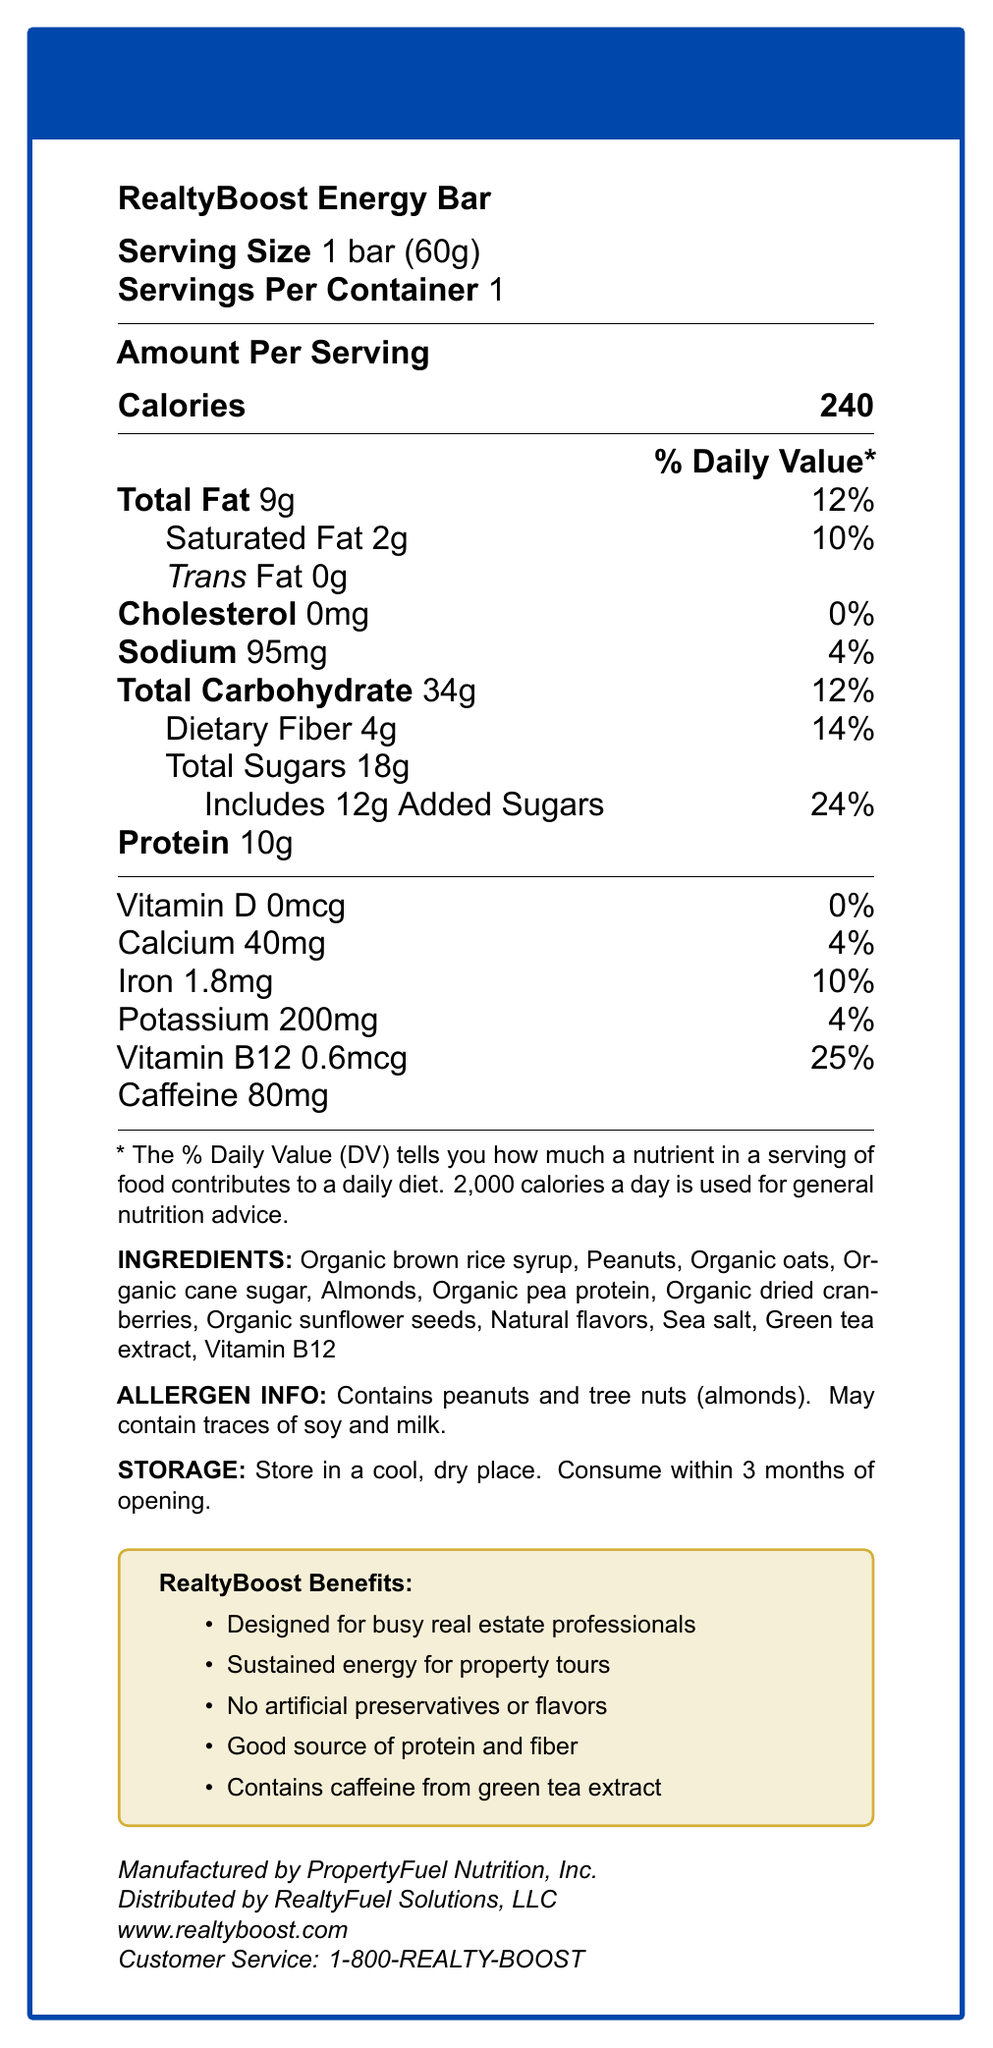How many calories are in one serving of RealtyBoost Energy Bar? The document states that one serving of the RealtyBoost Energy Bar contains 240 calories.
Answer: 240 What is the serving size for the RealtyBoost Energy Bar? The serving size is specified as "1 bar (60g)" in the document.
Answer: 1 bar (60g) What percentage of the daily value of calcium does one serving provide? The document mentions that one serving of the energy bar provides 4% of the daily value for calcium.
Answer: 4% Does the RealtyBoost Energy Bar contain any cholesterol? The document lists "Cholesterol 0mg" with a daily value of "0%", indicating no cholesterol content.
Answer: No What is the total amount of carbohydrates in one serving? The document indicates that one serving contains 34 grams of total carbohydrates.
Answer: 34g Which ingredient in the RealtyBoost Energy Bar contains caffeine? The document lists caffeine content and mentions "Green tea extract" as an ingredient, implying that caffeine comes from green tea extract.
Answer: Green tea extract How much dietary fiber does one bar contain? The document notes that one serving contains 4 grams of dietary fiber.
Answer: 4g Where should the RealtyBoost Energy Bar be stored? The storage instructions specify that the bar should be stored in a cool, dry place.
Answer: In a cool, dry place What is the daily value percentage of saturated fat in one serving? According to the document, the daily value percentage for saturated fat is 10%.
Answer: 10% How many grams of protein does one serving provide? The document states that one serving provides 10 grams of protein.
Answer: 10g What is the name of the manufacturer of RealtyBoost Energy Bar? The manufacturer is listed as PropertyFuel Nutrition, Inc.
Answer: PropertyFuel Nutrition, Inc. Who distributes the RealtyBoost Energy Bar? A. PropertyFuel Nutrition, Inc. B. RealtyFuel Solutions, LLC C. Green Tea Extract Co. D. Real Estate Agents Association The document states that RealtyFuel Solutions, LLC is the distributor of the energy bar.
Answer: B What is the daily value percentage of iron in one serving? i. 4% ii. 10% iii. 14% iv. 24% The document lists the daily value percentage of iron as 10%.
Answer: ii Does the RealtyBoost Energy Bar contain any artificial preservatives or flavors? One of the marketing claims is that there are no artificial preservatives or flavors in the energy bar.
Answer: No Can this document tell you how many bars come in a case of RealtyBoost Energy Bars? The document provides information about serving size and servings per container but does not mention the packaging details like number of bars per case.
Answer: Cannot be determined Summarize the main idea of this Nutrition Facts Label. This summary integrates key points from the document, such as the target audience, purpose, nutritional content, ingredients, and other relevant details to provide a comprehensive overview of the information presented.
Answer: The RealtyBoost Energy Bar is a snack designed for busy real estate professionals to provide sustained energy during property tours. It offers 240 calories per bar, is a good source of protein and fiber, contains 80mg of caffeine from green tea extract, and has no artificial preservatives or flavors. The product also lists its ingredients, allergen information, and storage instructions. 